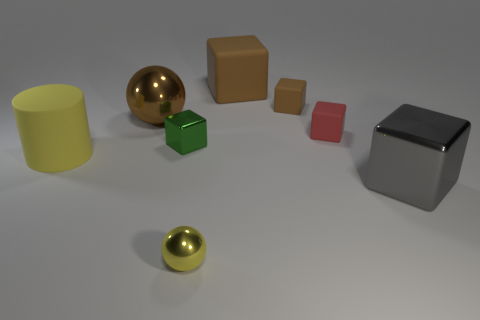There is a ball behind the gray metal thing; how big is it?
Offer a terse response. Large. There is a yellow cylinder that is left of the large gray object; are there any gray things to the right of it?
Your answer should be compact. Yes. Are the large cube that is in front of the large rubber block and the small red block made of the same material?
Give a very brief answer. No. How many rubber objects are behind the yellow matte object and on the left side of the small brown cube?
Your answer should be compact. 1. What number of red blocks are the same material as the yellow ball?
Offer a terse response. 0. There is a large ball that is made of the same material as the green cube; what is its color?
Make the answer very short. Brown. Are there fewer brown things than small brown matte cubes?
Provide a short and direct response. No. What is the material of the thing on the left side of the shiny ball that is left of the green metal cube that is to the left of the gray metallic object?
Give a very brief answer. Rubber. What material is the tiny brown cube?
Offer a very short reply. Rubber. Does the tiny object that is in front of the rubber cylinder have the same color as the rubber object that is in front of the small green block?
Keep it short and to the point. Yes. 